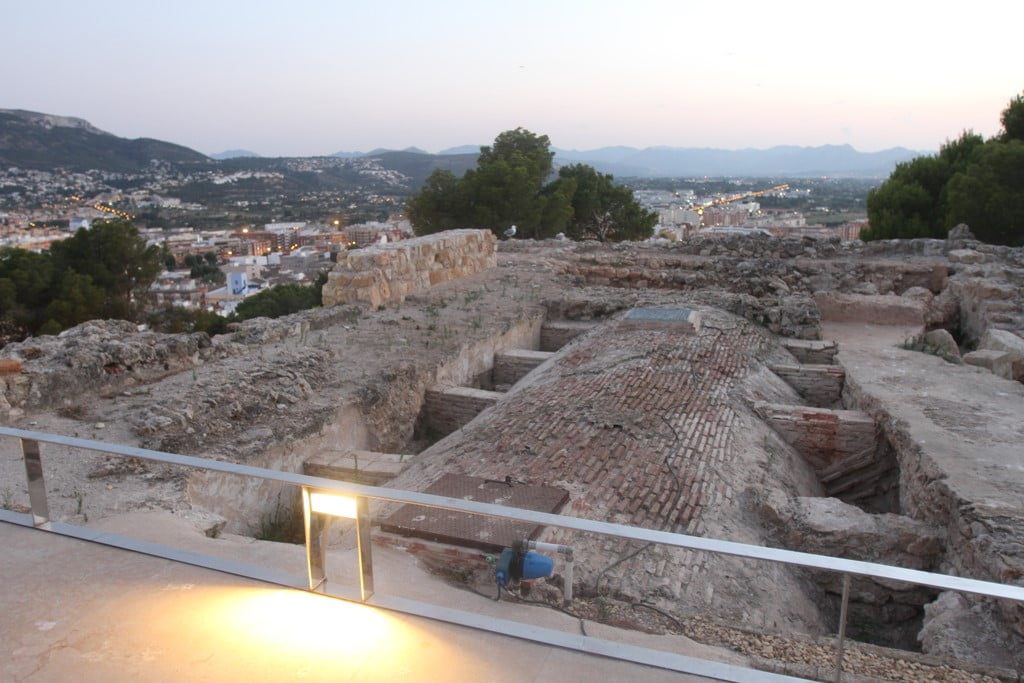What can you infer about the location of this historical site in relation to the modern city visible in the background? This historical site is positioned on elevated ground overlooking a modern cityscape, suggesting it was strategically important, likely for defensive purposes. Its prominence on a hill provides not only a tactical advantage but also symbolizes its historical importance, overseeing the urban expansion below. The juxtaposition of the ancient ruins against the modern city highlights a deep respect for historical heritage amidst urban development, offering a physical narrative of the city's evolution from its ancient roots to present day. How does this coexistence of old and new structures influence the cultural identity of the area? The coexistence of the ancient ruins with the modern cityscape enriches the cultural identity of the area, weaving a historical continuity that is palpable in the community's daily life. Such preservation amidst progression fosters a unique cultural milieu that embraces both history and modernity, offering residents and visitors alike a tangible connection to the past. This blend of eras not only enhances the city's charm but also serves as a constant reminder of the dynamic history that shapes the present and future cultural landscape. 